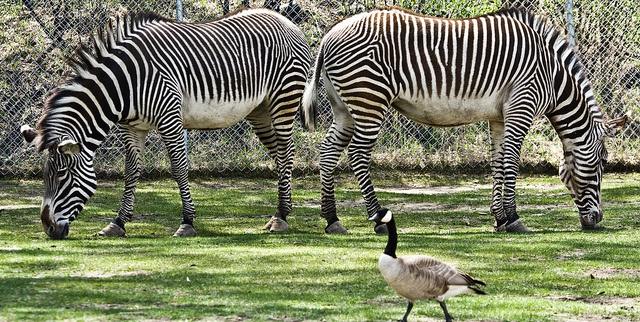Describe the objects in this image and their specific colors. I can see zebra in darkblue, black, lightgray, darkgray, and gray tones, zebra in darkblue, black, lightgray, gray, and darkgray tones, and bird in darkblue, black, darkgray, gray, and lightgray tones in this image. 